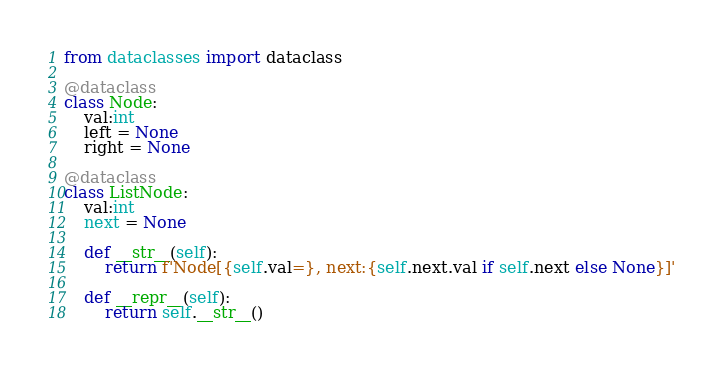<code> <loc_0><loc_0><loc_500><loc_500><_Python_>from dataclasses import dataclass

@dataclass
class Node:
    val:int
    left = None
    right = None

@dataclass
class ListNode:
    val:int
    next = None
    
    def __str__(self):
        return f'Node[{self.val=}, next:{self.next.val if self.next else None}]'
    
    def __repr__(self):
        return self.__str__()
</code> 